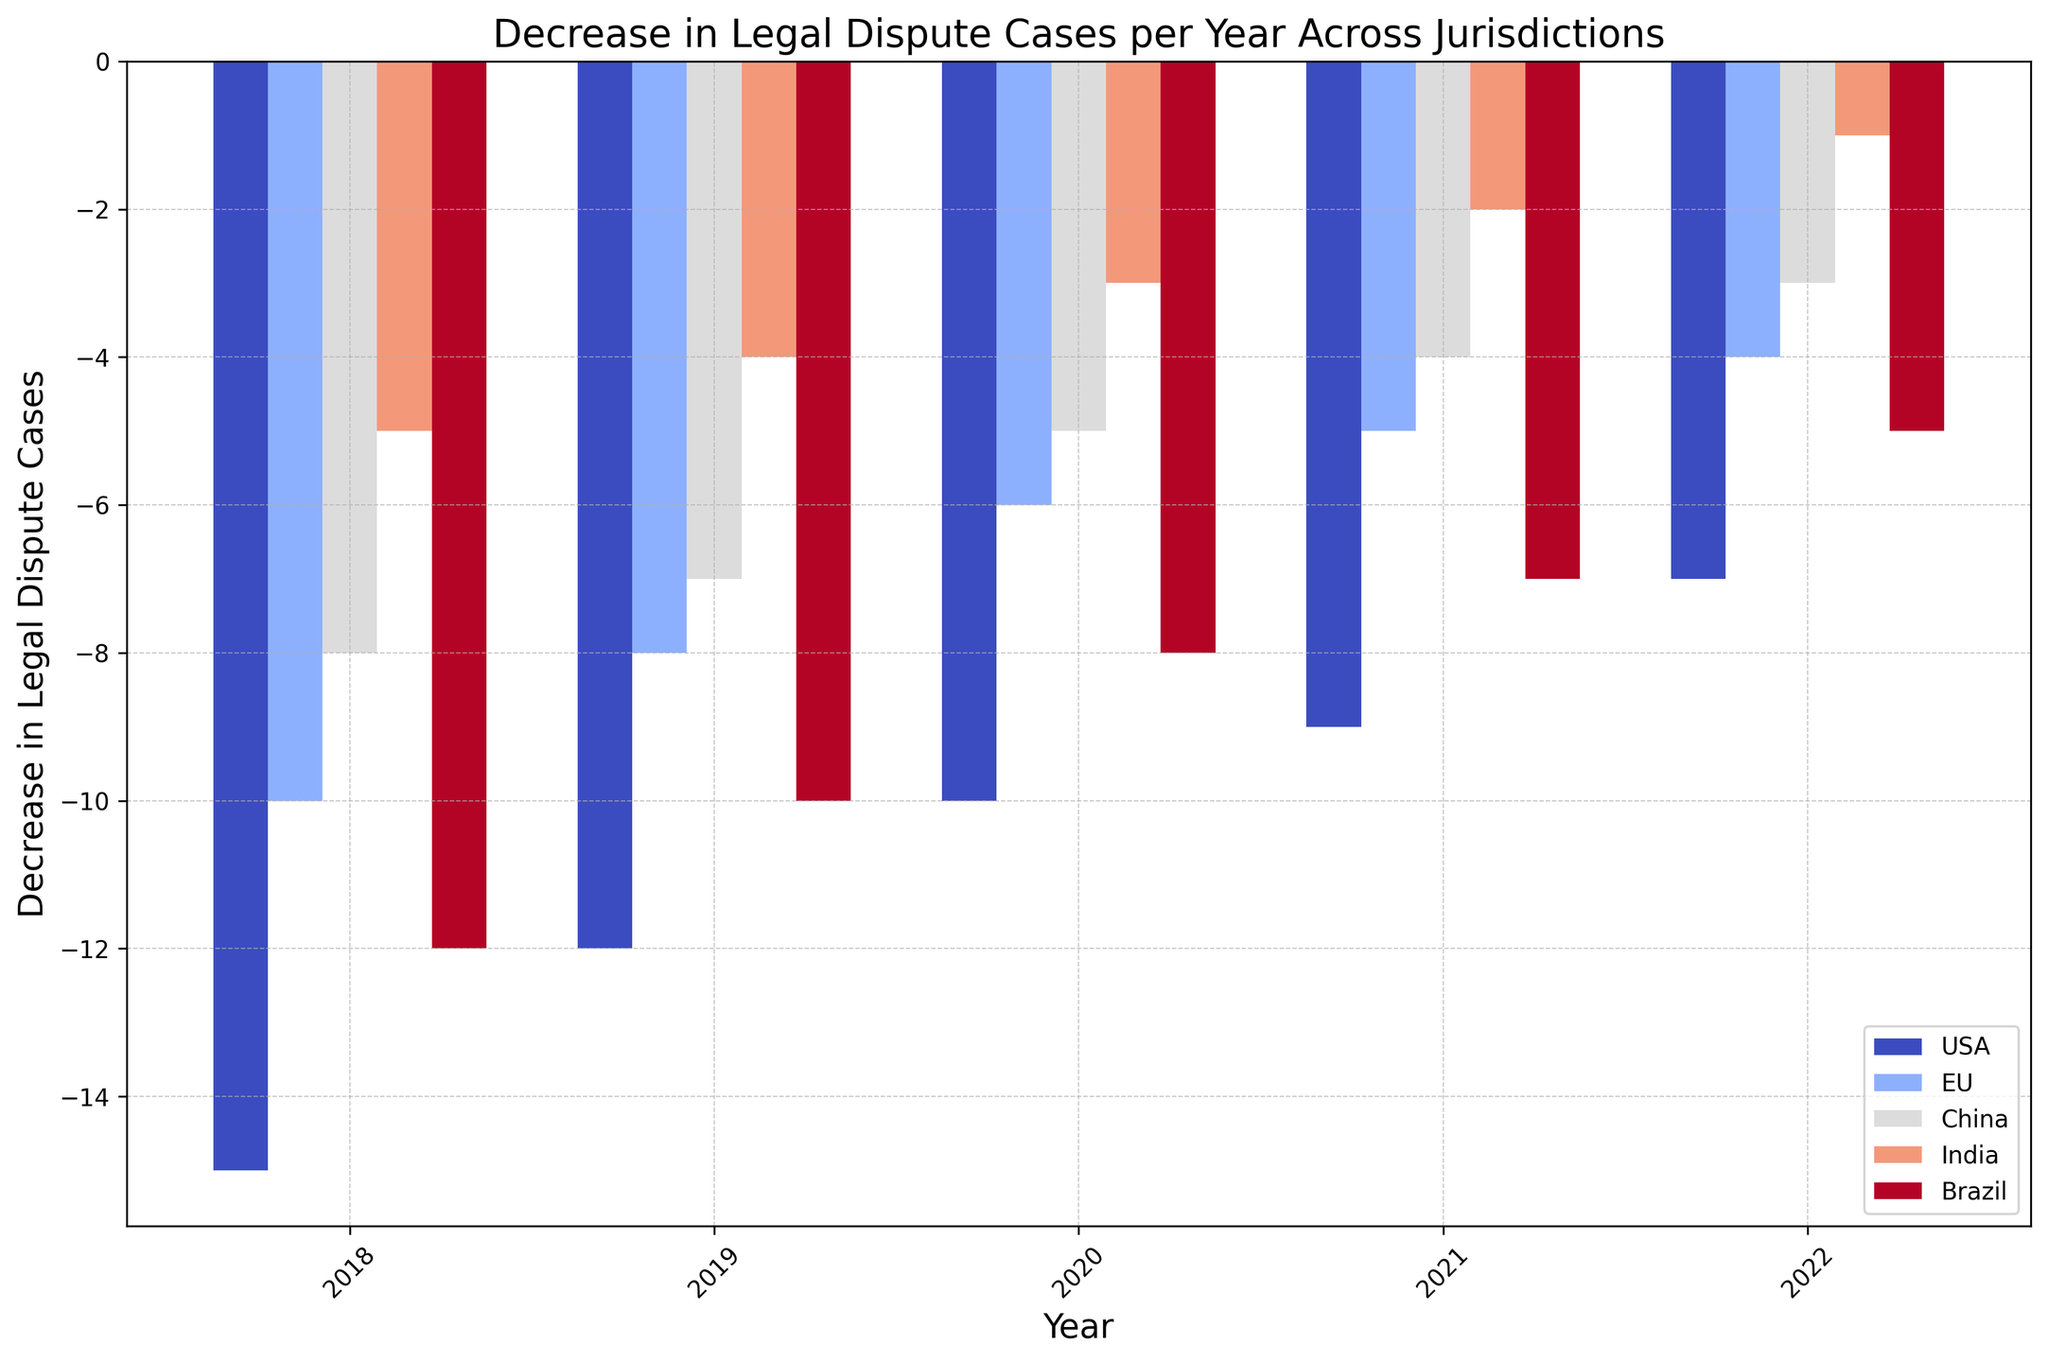Which jurisdiction saw the greatest decrease in legal dispute cases in 2018? By observing the height of the bars for 2018, we can see which bar is the tallest (most negative). The tallest bar is for the USA.
Answer: USA Which year did India experience the least decrease in legal disputes? By comparing the heights of the bars for India across all years, the bar for 2022 is the shortest (least negative).
Answer: 2022 How does the decrease in legal disputes in Brazil in 2020 compare to that in the EU in the same year? By comparing the heights of the bars for Brazil and the EU in 2020, Brazil's bar is taller (more negative) than the EU’s.
Answer: Brazil saw a greater decrease What's the total decrease in legal disputes for China from 2018 to 2019? Sum the decreases for China in 2018 and 2019: (-8) + (-7) = -15.
Answer: -15 Which jurisdiction had the smallest decrease in legal disputes in 2019? By observing the heights of the bars for each jurisdiction in 2019, India has the shortest bar (least negative).
Answer: India What's the average annual decrease in legal disputes for the USA from 2018 to 2022? Sum the decreases for the USA from 2018 to 2022: (-15) + (-12) + (-10) + (-9) + (-7) = -53. Divide by the number of years (5): -53 / 5 = -10.6.
Answer: -10.6 How does the decrease in legal disputes in the EU in 2022 compare to that in 2020? By comparing bar heights for the EU in both years, 2022's bar is shorter (less negative) than 2020’s.
Answer: Less in 2022 Which year exhibited the largest disparity in decreases between jurisdictions? By comparing the differences in bar heights for all years, 2018 shows the largest disparity, with the USA and India having a large difference.
Answer: 2018 What's the median decrease in legal disputes for Brazil from 2018 to 2022? List the decreases for Brazil: -12, -10, -8, -7, -5. The median is the middle value: -8.
Answer: -8 